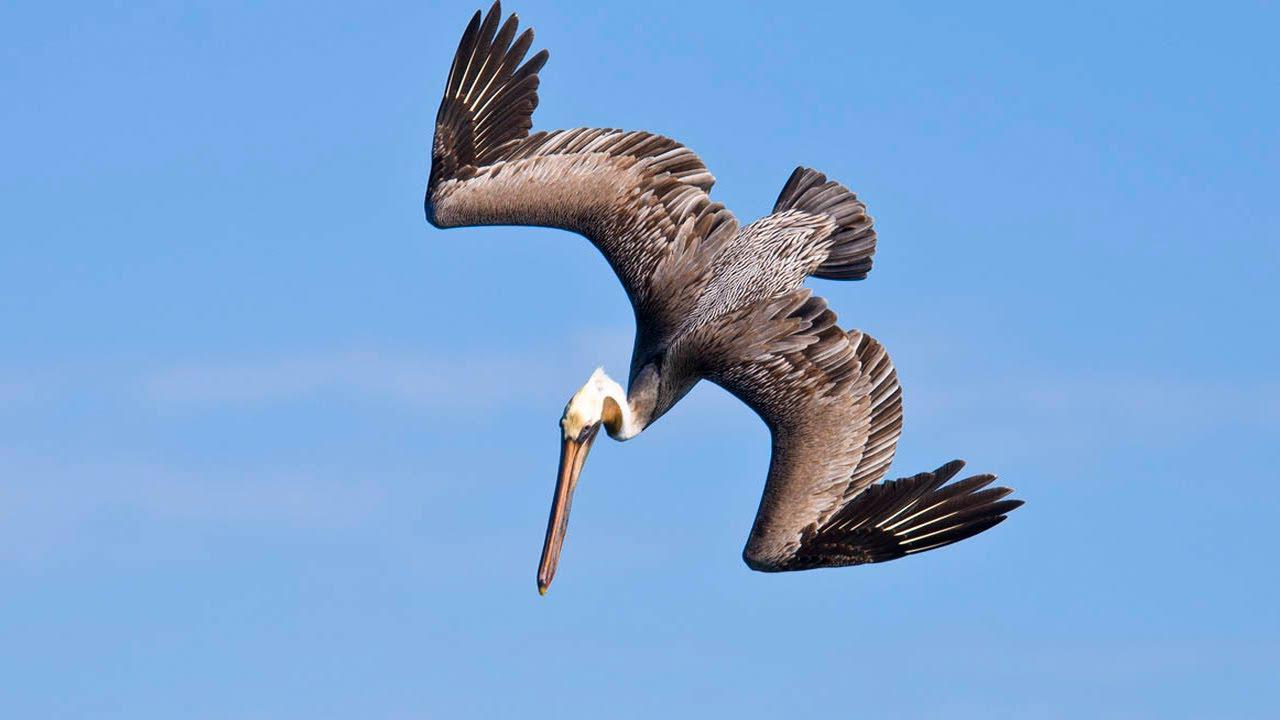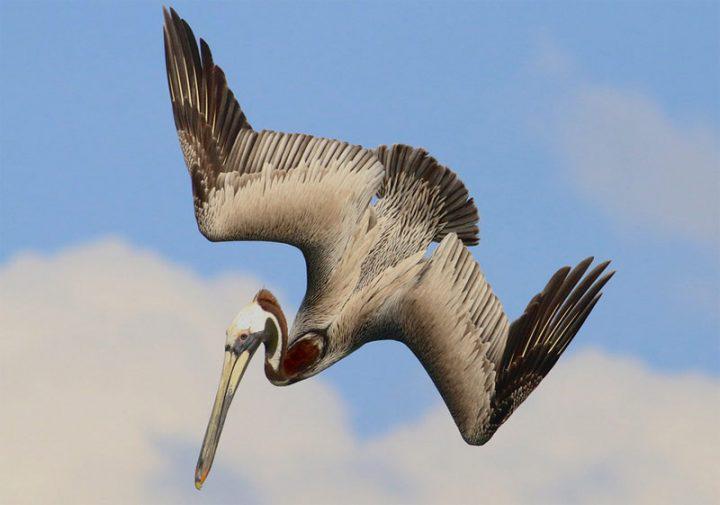The first image is the image on the left, the second image is the image on the right. Analyze the images presented: Is the assertion "Both images show diving pelicans, and the birds in the left and right images have their heads facing toward each other." valid? Answer yes or no. No. The first image is the image on the left, the second image is the image on the right. Considering the images on both sides, is "The birds in both images are diving into the water with their heads facing right." valid? Answer yes or no. No. 